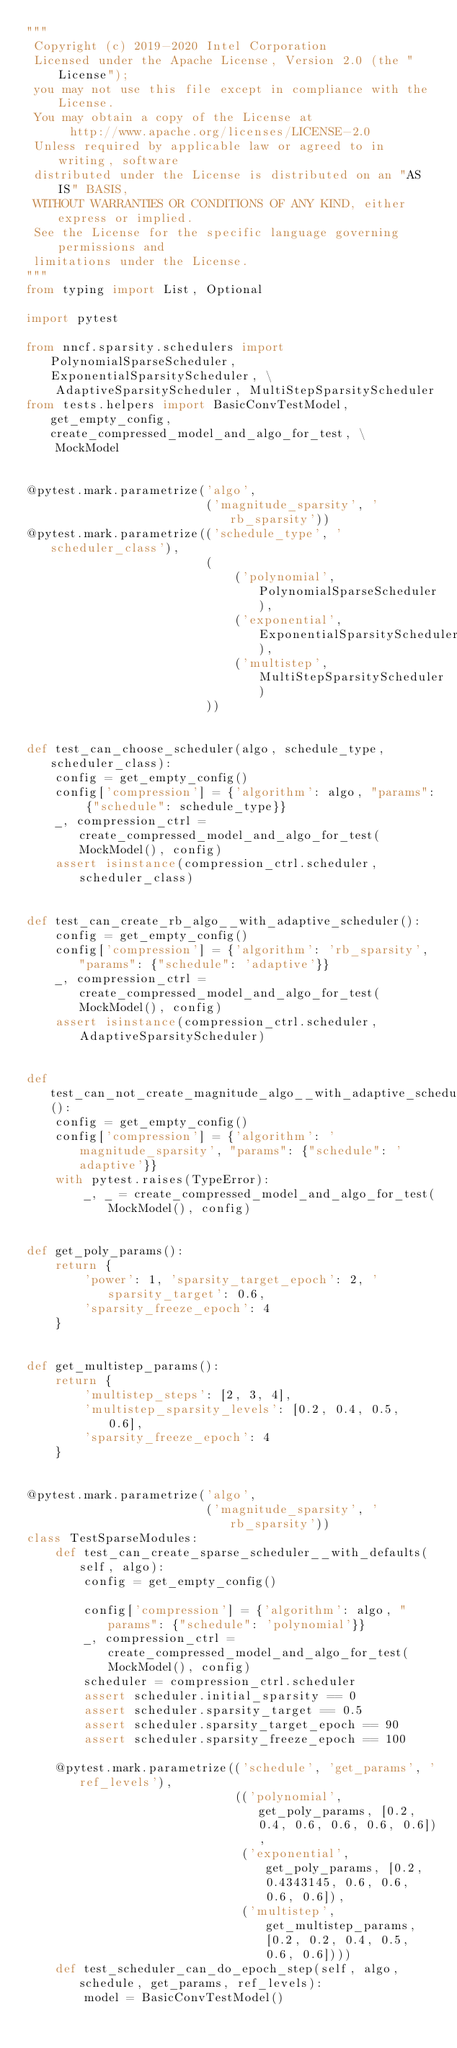<code> <loc_0><loc_0><loc_500><loc_500><_Python_>"""
 Copyright (c) 2019-2020 Intel Corporation
 Licensed under the Apache License, Version 2.0 (the "License");
 you may not use this file except in compliance with the License.
 You may obtain a copy of the License at
      http://www.apache.org/licenses/LICENSE-2.0
 Unless required by applicable law or agreed to in writing, software
 distributed under the License is distributed on an "AS IS" BASIS,
 WITHOUT WARRANTIES OR CONDITIONS OF ANY KIND, either express or implied.
 See the License for the specific language governing permissions and
 limitations under the License.
"""
from typing import List, Optional

import pytest

from nncf.sparsity.schedulers import PolynomialSparseScheduler, ExponentialSparsityScheduler, \
    AdaptiveSparsityScheduler, MultiStepSparsityScheduler
from tests.helpers import BasicConvTestModel, get_empty_config, create_compressed_model_and_algo_for_test, \
    MockModel


@pytest.mark.parametrize('algo',
                         ('magnitude_sparsity', 'rb_sparsity'))
@pytest.mark.parametrize(('schedule_type', 'scheduler_class'),
                         (
                             ('polynomial', PolynomialSparseScheduler),
                             ('exponential', ExponentialSparsityScheduler),
                             ('multistep', MultiStepSparsityScheduler)
                         ))


def test_can_choose_scheduler(algo, schedule_type, scheduler_class):
    config = get_empty_config()
    config['compression'] = {'algorithm': algo, "params": {"schedule": schedule_type}}
    _, compression_ctrl = create_compressed_model_and_algo_for_test(MockModel(), config)
    assert isinstance(compression_ctrl.scheduler, scheduler_class)


def test_can_create_rb_algo__with_adaptive_scheduler():
    config = get_empty_config()
    config['compression'] = {'algorithm': 'rb_sparsity', "params": {"schedule": 'adaptive'}}
    _, compression_ctrl = create_compressed_model_and_algo_for_test(MockModel(), config)
    assert isinstance(compression_ctrl.scheduler, AdaptiveSparsityScheduler)


def test_can_not_create_magnitude_algo__with_adaptive_scheduler():
    config = get_empty_config()
    config['compression'] = {'algorithm': 'magnitude_sparsity', "params": {"schedule": 'adaptive'}}
    with pytest.raises(TypeError):
        _, _ = create_compressed_model_and_algo_for_test(MockModel(), config)


def get_poly_params():
    return {
        'power': 1, 'sparsity_target_epoch': 2, 'sparsity_target': 0.6,
        'sparsity_freeze_epoch': 4
    }


def get_multistep_params():
    return {
        'multistep_steps': [2, 3, 4],
        'multistep_sparsity_levels': [0.2, 0.4, 0.5, 0.6],
        'sparsity_freeze_epoch': 4
    }


@pytest.mark.parametrize('algo',
                         ('magnitude_sparsity', 'rb_sparsity'))
class TestSparseModules:
    def test_can_create_sparse_scheduler__with_defaults(self, algo):
        config = get_empty_config()

        config['compression'] = {'algorithm': algo, "params": {"schedule": 'polynomial'}}
        _, compression_ctrl = create_compressed_model_and_algo_for_test(MockModel(), config)
        scheduler = compression_ctrl.scheduler
        assert scheduler.initial_sparsity == 0
        assert scheduler.sparsity_target == 0.5
        assert scheduler.sparsity_target_epoch == 90
        assert scheduler.sparsity_freeze_epoch == 100

    @pytest.mark.parametrize(('schedule', 'get_params', 'ref_levels'),
                             (('polynomial', get_poly_params, [0.2, 0.4, 0.6, 0.6, 0.6, 0.6]),
                              ('exponential', get_poly_params, [0.2, 0.4343145, 0.6, 0.6, 0.6, 0.6]),
                              ('multistep', get_multistep_params, [0.2, 0.2, 0.4, 0.5, 0.6, 0.6])))
    def test_scheduler_can_do_epoch_step(self, algo, schedule, get_params, ref_levels):
        model = BasicConvTestModel()</code> 